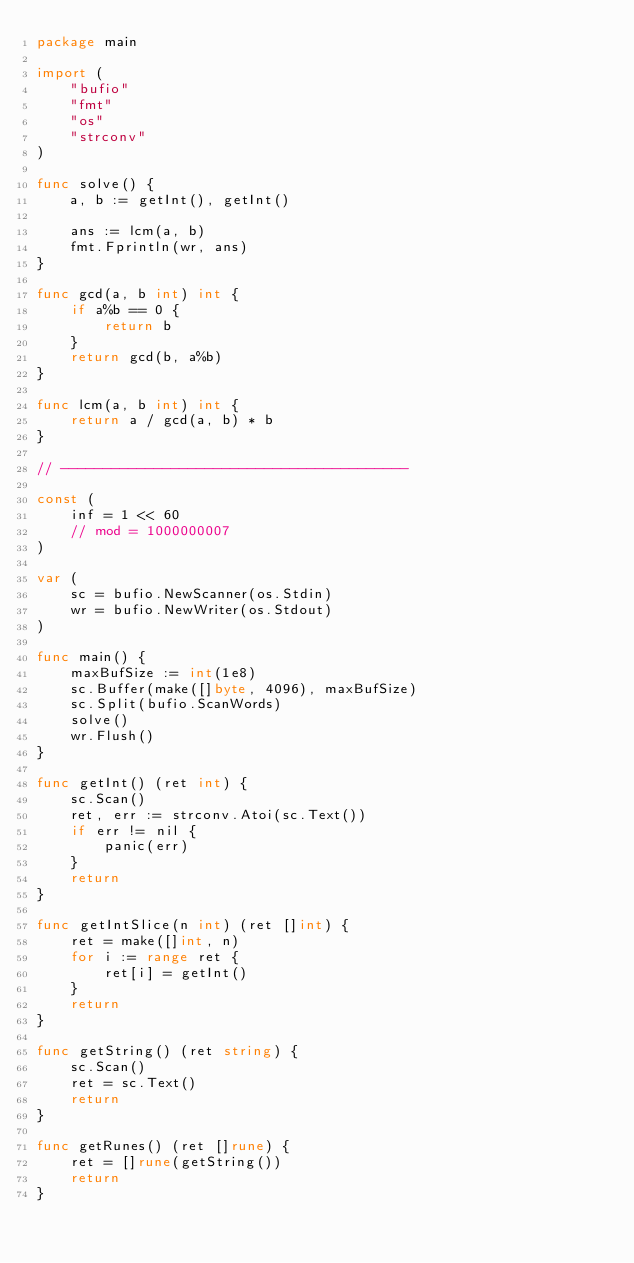<code> <loc_0><loc_0><loc_500><loc_500><_Go_>package main

import (
	"bufio"
	"fmt"
	"os"
	"strconv"
)

func solve() {
	a, b := getInt(), getInt()

	ans := lcm(a, b)
	fmt.Fprintln(wr, ans)
}

func gcd(a, b int) int {
	if a%b == 0 {
		return b
	}
	return gcd(b, a%b)
}

func lcm(a, b int) int {
	return a / gcd(a, b) * b
}

// -----------------------------------------

const (
	inf = 1 << 60
	// mod = 1000000007
)

var (
	sc = bufio.NewScanner(os.Stdin)
	wr = bufio.NewWriter(os.Stdout)
)

func main() {
	maxBufSize := int(1e8)
	sc.Buffer(make([]byte, 4096), maxBufSize)
	sc.Split(bufio.ScanWords)
	solve()
	wr.Flush()
}

func getInt() (ret int) {
	sc.Scan()
	ret, err := strconv.Atoi(sc.Text())
	if err != nil {
		panic(err)
	}
	return
}

func getIntSlice(n int) (ret []int) {
	ret = make([]int, n)
	for i := range ret {
		ret[i] = getInt()
	}
	return
}

func getString() (ret string) {
	sc.Scan()
	ret = sc.Text()
	return
}

func getRunes() (ret []rune) {
	ret = []rune(getString())
	return
}
</code> 